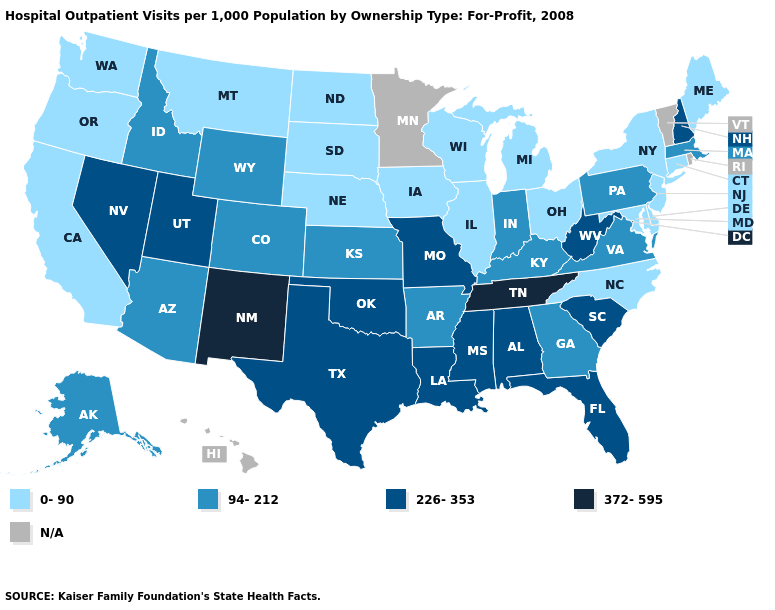Among the states that border Rhode Island , does Massachusetts have the highest value?
Answer briefly. Yes. Which states have the highest value in the USA?
Write a very short answer. New Mexico, Tennessee. Does Maryland have the lowest value in the South?
Keep it brief. Yes. What is the value of Virginia?
Answer briefly. 94-212. What is the value of North Dakota?
Short answer required. 0-90. What is the value of New Mexico?
Answer briefly. 372-595. Which states have the highest value in the USA?
Answer briefly. New Mexico, Tennessee. Among the states that border Oklahoma , which have the highest value?
Write a very short answer. New Mexico. Name the states that have a value in the range N/A?
Write a very short answer. Hawaii, Minnesota, Rhode Island, Vermont. Among the states that border Tennessee , which have the highest value?
Answer briefly. Alabama, Mississippi, Missouri. What is the lowest value in the USA?
Quick response, please. 0-90. What is the highest value in states that border Iowa?
Answer briefly. 226-353. Which states have the highest value in the USA?
Answer briefly. New Mexico, Tennessee. Which states hav the highest value in the MidWest?
Give a very brief answer. Missouri. 